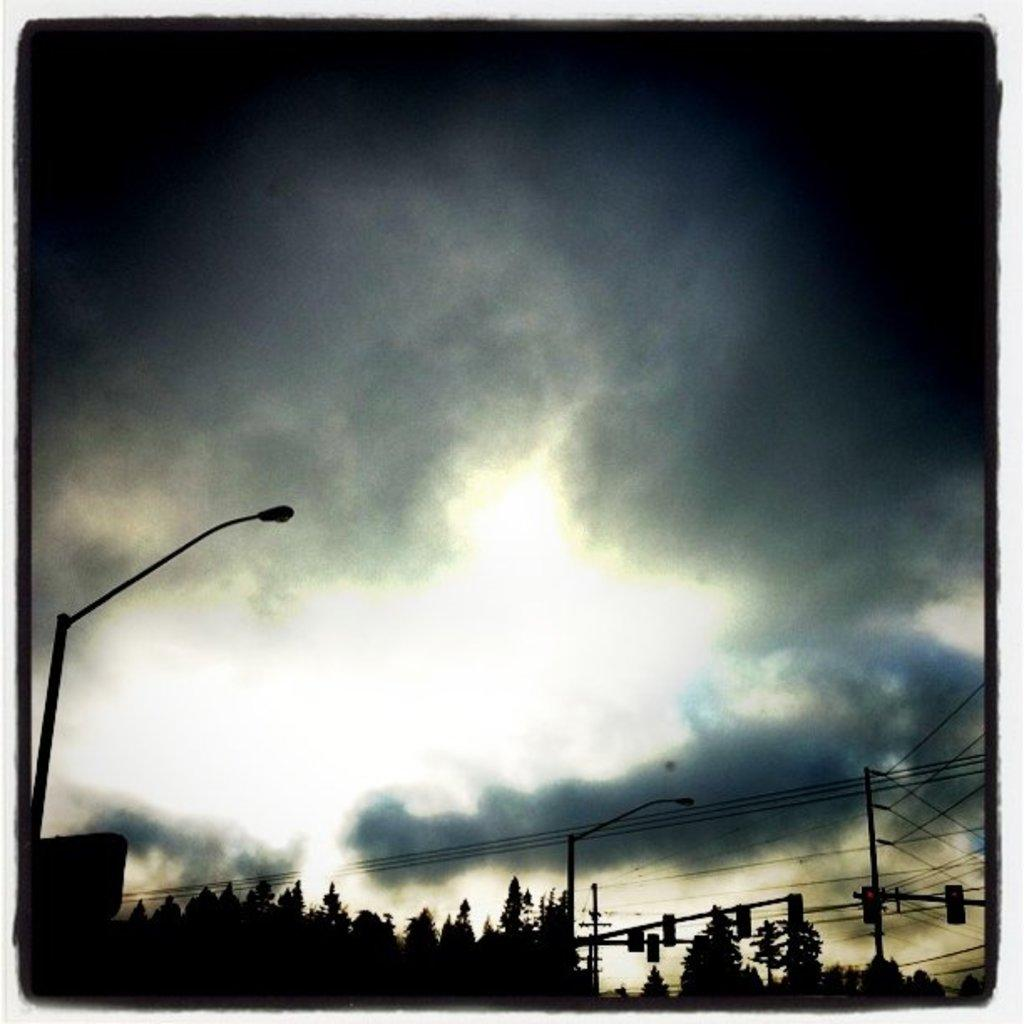What is the main subject of the image? There is a dark picture of trees in the image. What structure can be seen in the image? There is a pole with a light in the image. What is connected to the pole? There are wires connected to the pole in the image. What can be seen in the background of the image? There is a sky visible in the image. What is the weather like in the image? Dark clouds are present in the sky, suggesting a potentially stormy or overcast day. What type of skin condition can be seen on the trees in the image? There is no indication of a skin condition on the trees in the image; they appear to be healthy and dark due to the lighting or filter used. 